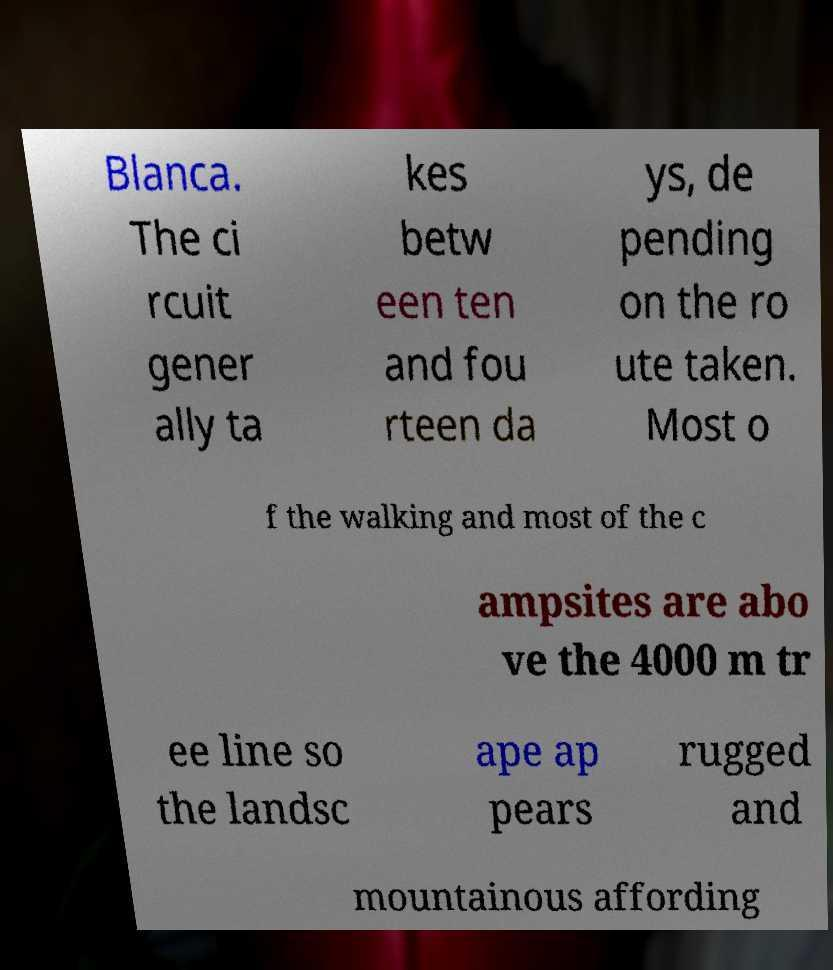Could you assist in decoding the text presented in this image and type it out clearly? Blanca. The ci rcuit gener ally ta kes betw een ten and fou rteen da ys, de pending on the ro ute taken. Most o f the walking and most of the c ampsites are abo ve the 4000 m tr ee line so the landsc ape ap pears rugged and mountainous affording 